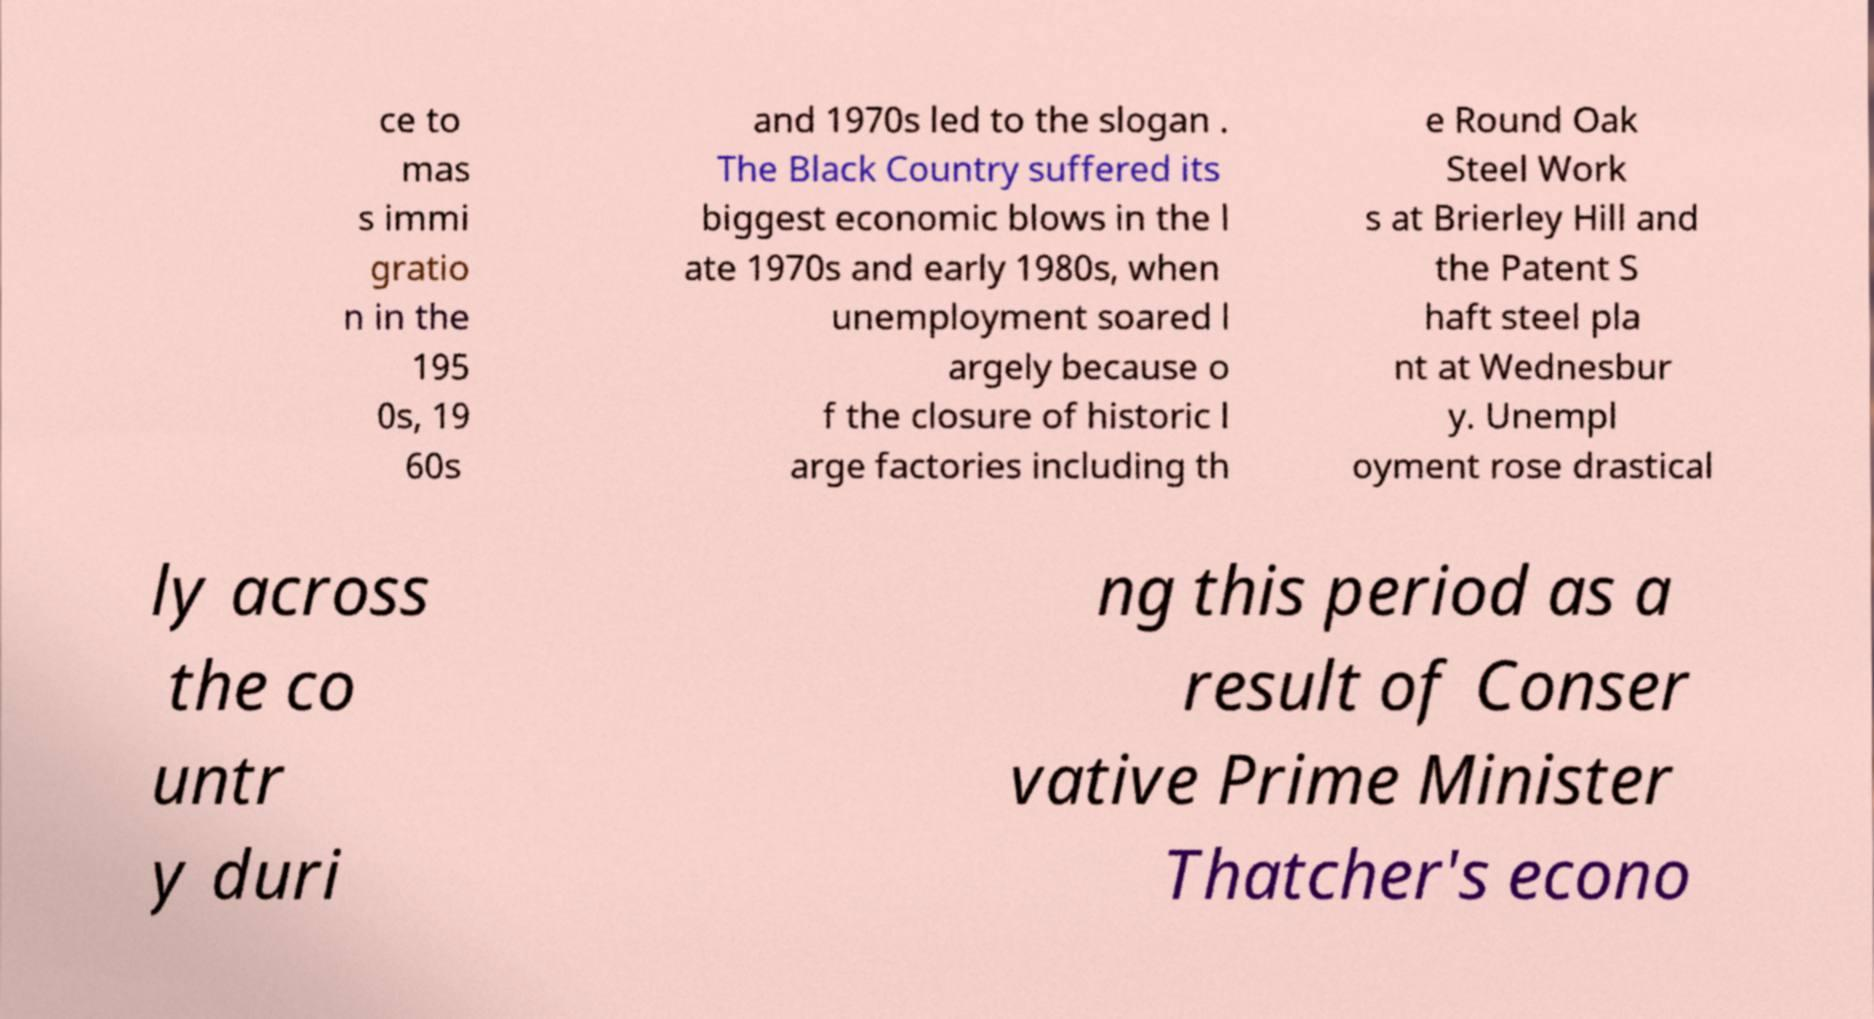What messages or text are displayed in this image? I need them in a readable, typed format. ce to mas s immi gratio n in the 195 0s, 19 60s and 1970s led to the slogan . The Black Country suffered its biggest economic blows in the l ate 1970s and early 1980s, when unemployment soared l argely because o f the closure of historic l arge factories including th e Round Oak Steel Work s at Brierley Hill and the Patent S haft steel pla nt at Wednesbur y. Unempl oyment rose drastical ly across the co untr y duri ng this period as a result of Conser vative Prime Minister Thatcher's econo 